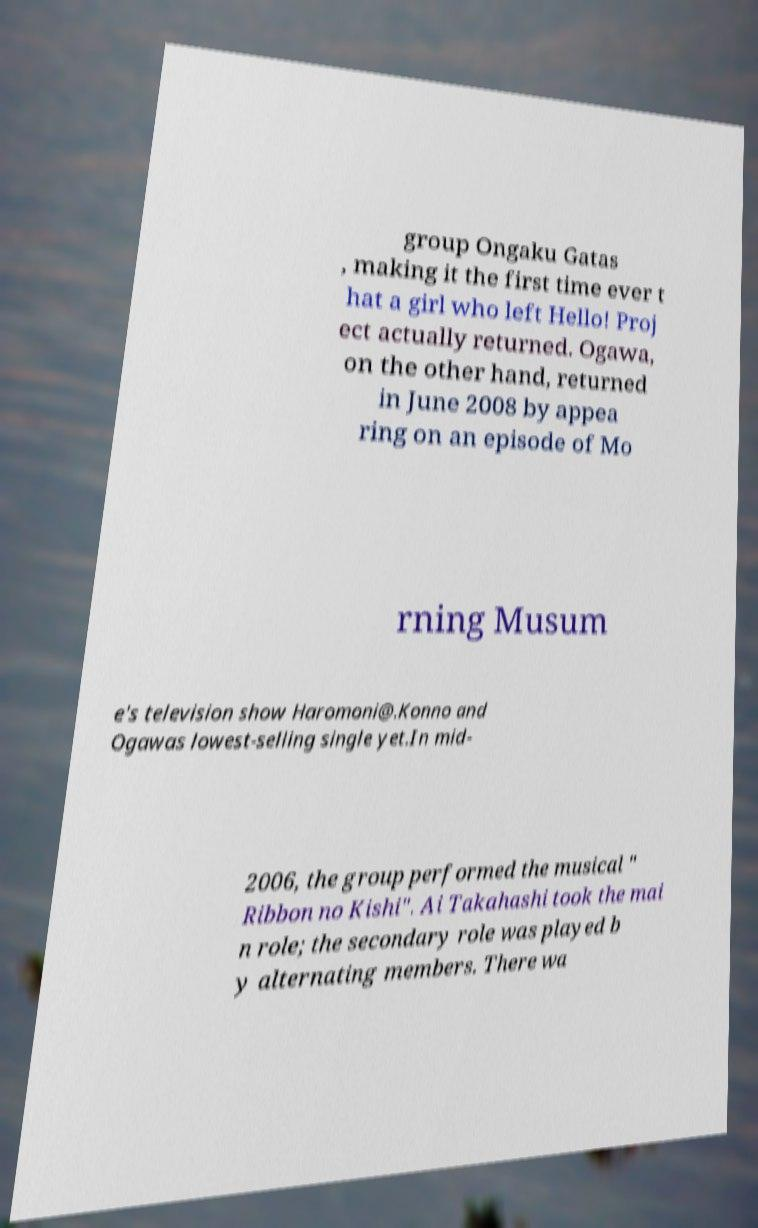For documentation purposes, I need the text within this image transcribed. Could you provide that? group Ongaku Gatas , making it the first time ever t hat a girl who left Hello! Proj ect actually returned. Ogawa, on the other hand, returned in June 2008 by appea ring on an episode of Mo rning Musum e's television show Haromoni@.Konno and Ogawas lowest-selling single yet.In mid- 2006, the group performed the musical " Ribbon no Kishi". Ai Takahashi took the mai n role; the secondary role was played b y alternating members. There wa 